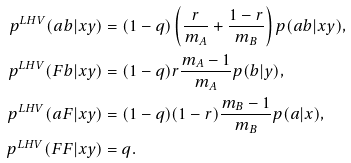<formula> <loc_0><loc_0><loc_500><loc_500>p ^ { L H V } ( a b | x y ) & = ( 1 - q ) \left ( \frac { r } { m _ { A } } + \frac { 1 - r } { m _ { B } } \right ) p ( a b | x y ) , \\ p ^ { L H V } ( F b | x y ) & = ( 1 - q ) r \frac { m _ { A } - 1 } { m _ { A } } p ( b | y ) , \\ p ^ { L H V } ( a F | x y ) & = ( 1 - q ) ( 1 - r ) \frac { m _ { B } - 1 } { m _ { B } } p ( a | x ) , \\ p ^ { L H V } ( F F | x y ) & = q .</formula> 